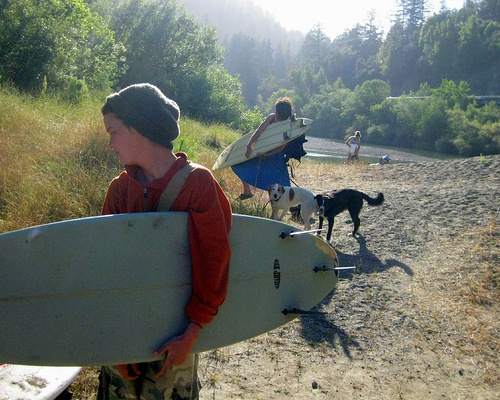Describe the objects in this image and their specific colors. I can see surfboard in darkgreen, gray, purple, and black tones, people in darkgreen, black, maroon, brown, and darkblue tones, people in darkgreen, navy, gray, black, and darkblue tones, surfboard in darkgreen, gray, and darkgray tones, and dog in darkgreen, black, gray, and darkgray tones in this image. 